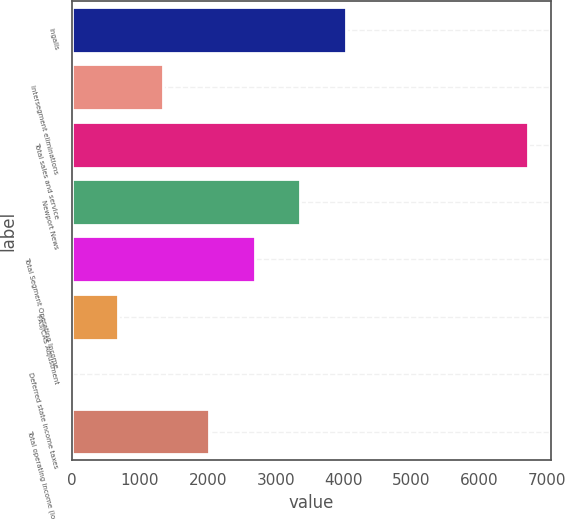Convert chart. <chart><loc_0><loc_0><loc_500><loc_500><bar_chart><fcel>Ingalls<fcel>Intersegment eliminations<fcel>Total sales and service<fcel>Newport News<fcel>Total Segment Operating Income<fcel>FAS/CAS Adjustment<fcel>Deferred state income taxes<fcel>Total operating income (loss)<nl><fcel>4035<fcel>1347<fcel>6723<fcel>3363<fcel>2691<fcel>675<fcel>3<fcel>2019<nl></chart> 